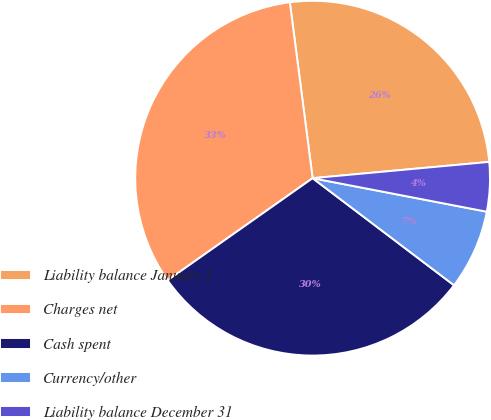Convert chart. <chart><loc_0><loc_0><loc_500><loc_500><pie_chart><fcel>Liability balance January 1<fcel>Charges net<fcel>Cash spent<fcel>Currency/other<fcel>Liability balance December 31<nl><fcel>25.59%<fcel>32.72%<fcel>29.92%<fcel>7.29%<fcel>4.49%<nl></chart> 